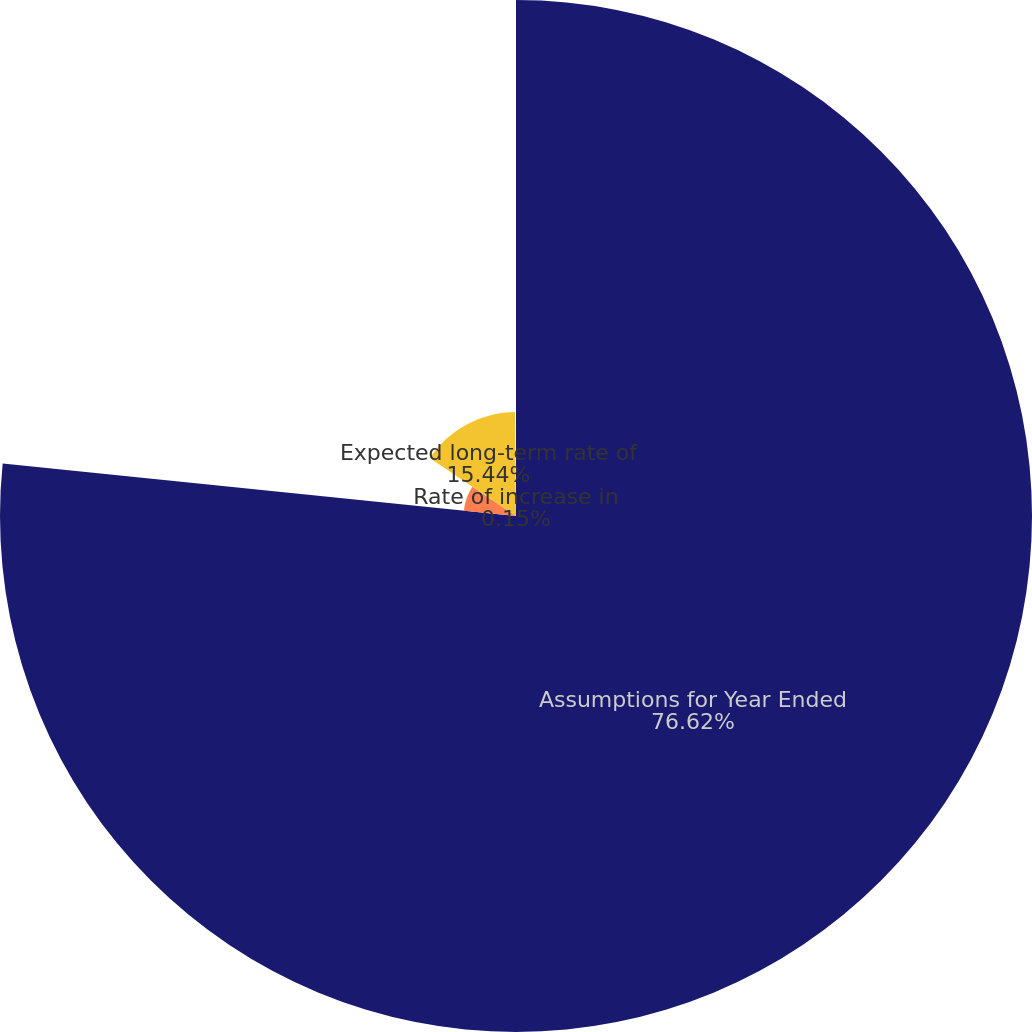Convert chart to OTSL. <chart><loc_0><loc_0><loc_500><loc_500><pie_chart><fcel>Assumptions for Year Ended<fcel>Discount rate<fcel>Expected long-term rate of<fcel>Rate of increase in<nl><fcel>76.62%<fcel>7.79%<fcel>15.44%<fcel>0.15%<nl></chart> 